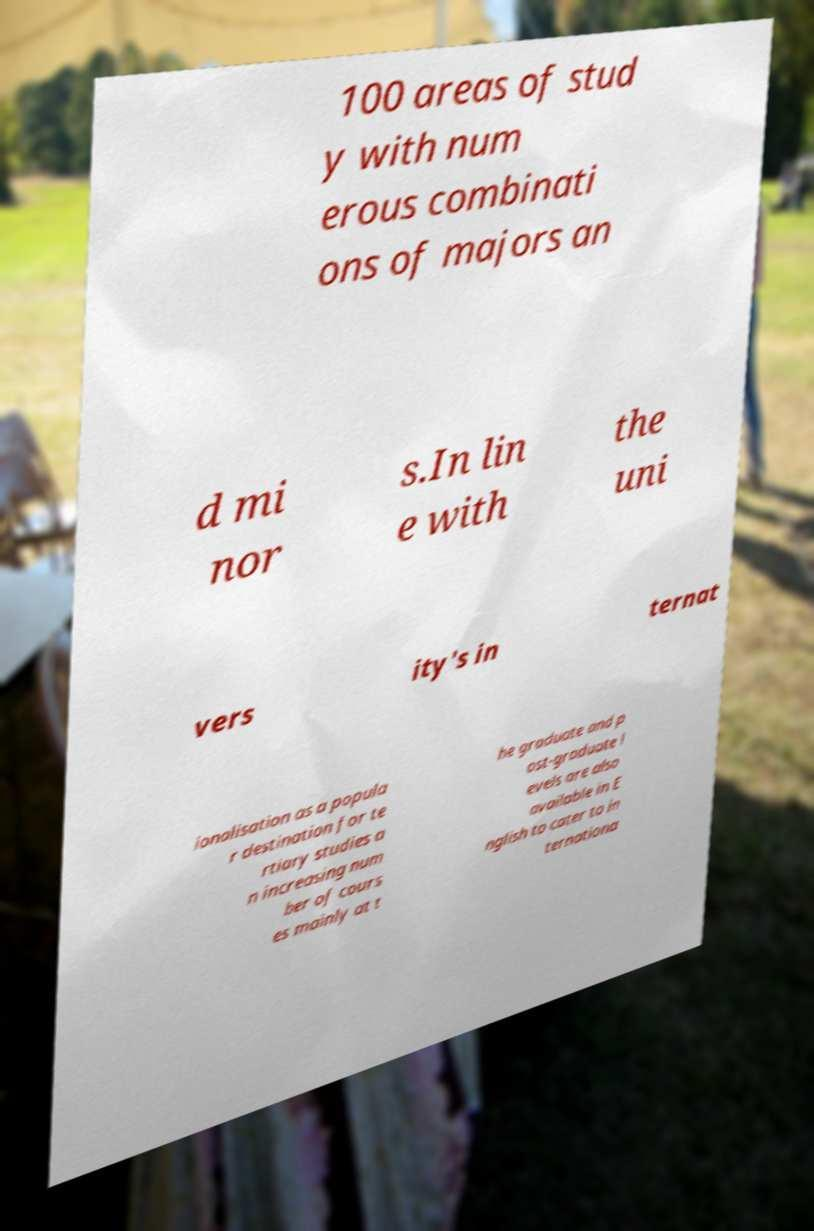There's text embedded in this image that I need extracted. Can you transcribe it verbatim? 100 areas of stud y with num erous combinati ons of majors an d mi nor s.In lin e with the uni vers ity's in ternat ionalisation as a popula r destination for te rtiary studies a n increasing num ber of cours es mainly at t he graduate and p ost-graduate l evels are also available in E nglish to cater to in ternationa 